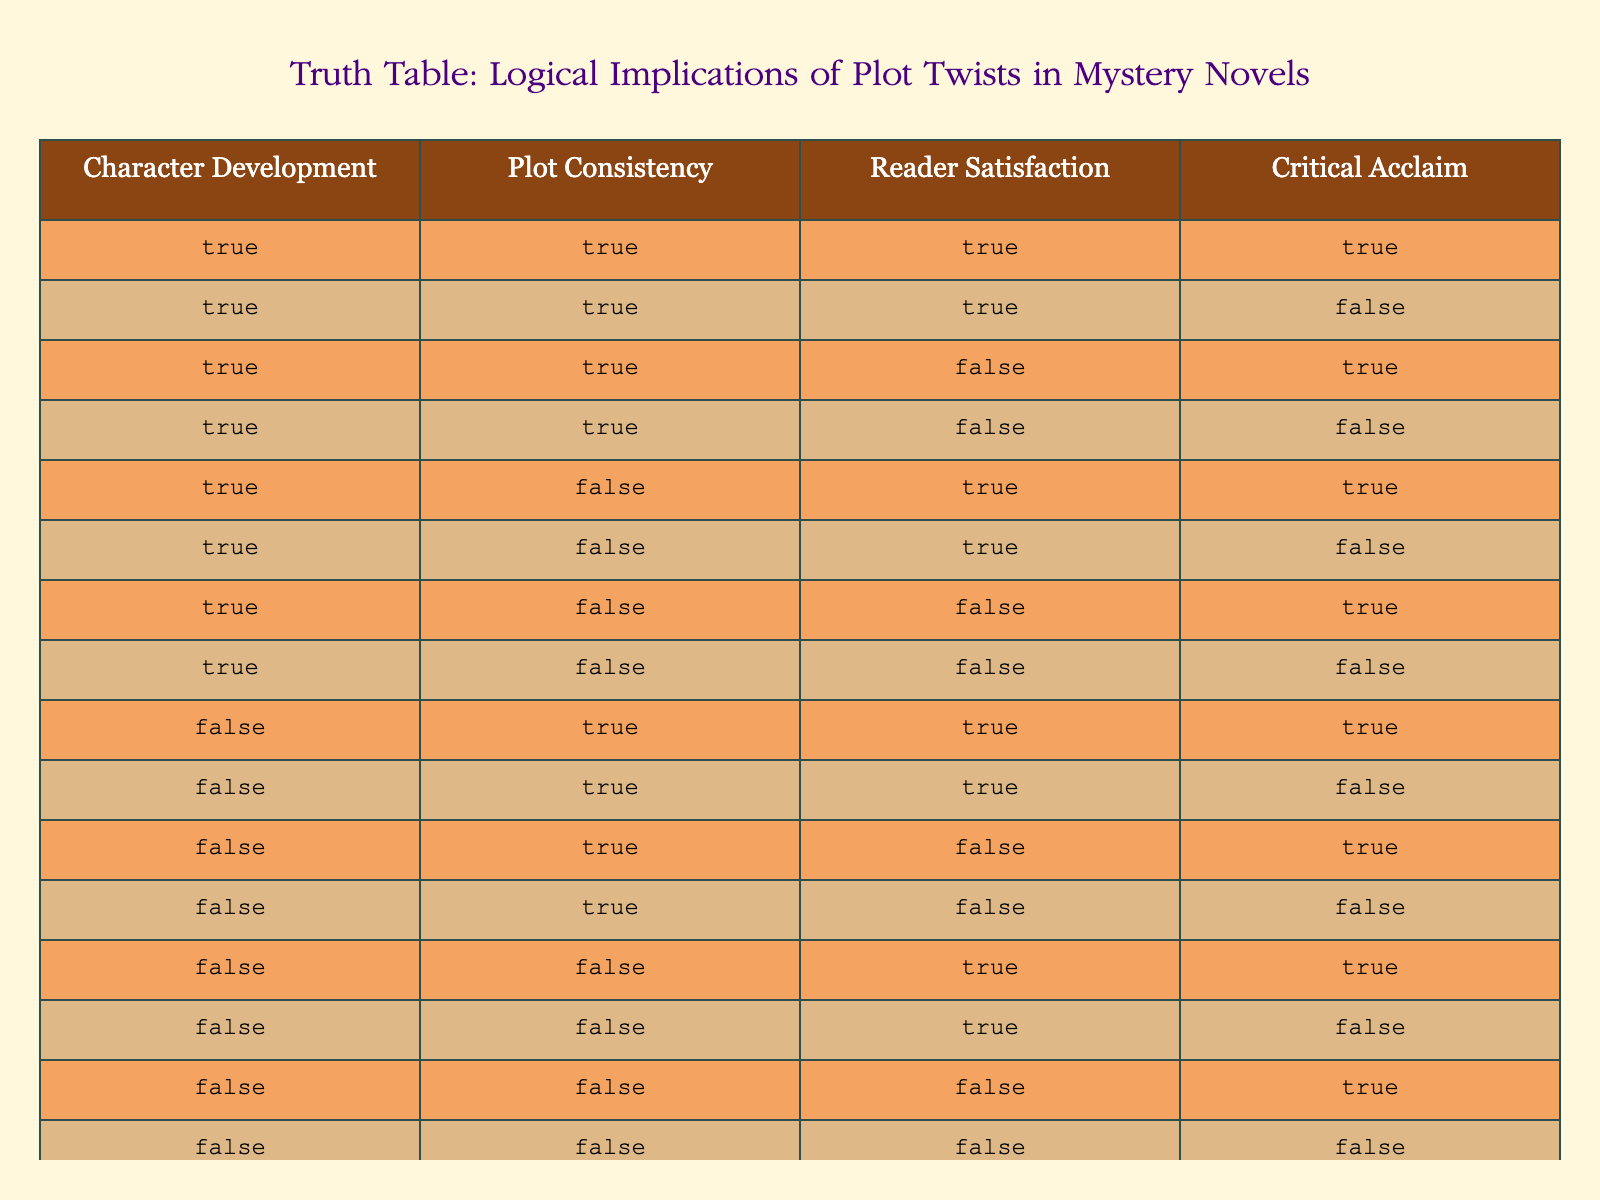What is the number of cases where Character Development and Plot Consistency are both True? To find this, we’ll check the rows of the table for cases where both Character Development and Plot Consistency are marked as True. There are four instances: (True, True, True, True), (True, True, True, False), (True, True, False, True), and (True, True, False, False), making a total of 4 cases.
Answer: 4 Is there any case where Reader Satisfaction is True and Critical Acclaim is False? We must look for rows where Reader Satisfaction equals True while Critical Acclaim equals False. In the table, there are zero instances of this condition, as the only combinations of True for Reader Satisfaction correspond with either True or True for Critical Acclaim.
Answer: No How many rows show a correlation where Character Development is False and Reader Satisfaction is True? In the table, counting the rows where Character Development is marked as False and Reader Satisfaction as True, there are three instances: (False, True, True, True), (False, True, True, False), and (False, False, True, True), totaling 3 rows.
Answer: 3 Which combination has the highest occurrence of True values across Character Development, Plot Consistency, Reader Satisfaction, and Critical Acclaim? By analyzing the table, the combination that maximizes True values is (True, True, True, True), which features 4 True values. Analyzing all combinations, there is no variation with higher than 4 True values.
Answer: (True, True, True, True) Is Critical Acclaim always True when both Character Development and Plot Consistency are True? Check the table for all instances where Character Development and Plot Consistency are both True. In the rows (True, True, True, True), (True, True, True, False), (True, True, False, True), and (True, True, False, False), it can be observed that Critical Acclaim is not always True; thus, the statement is False.
Answer: No What is the average number of True values per case in rows where Character Development is True? In the rows where Character Development is True, we have 8 cases. The total count of True values is (3 + 3 + 2 + 2 + 2 + 2 + 1 + 1) = 16. To find the average, divide 16 by the number of cases, which gives us an average of 16/8 = 2.
Answer: 2 Are there more cases with False for both Plot Consistency and Reader Satisfaction than for True? We count the cases where Plot Consistency and Reader Satisfaction are both False: there are 4 instances: (False, False, False, True), (False, False, False, False). Now counting for True in Plot Consistency and Reader Satisfaction, there are 3 instances: (True, True, True, True), (True, True, False, True), (True, False, True, True), so indeed there are more False cases.
Answer: Yes How many combinations result in Reader Satisfaction being False? We scan for rows where Reader Satisfaction equals False. These cases are (True, True, False, True), (True, True, False, False), (True, False, False, True), (True, False, False, False), (False, True, False, True), etc. Counting these means we find a total of 8 rows where Reader Satisfaction is False.
Answer: 8 